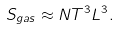Convert formula to latex. <formula><loc_0><loc_0><loc_500><loc_500>S _ { g a s } \approx N T ^ { 3 } L ^ { 3 } .</formula> 